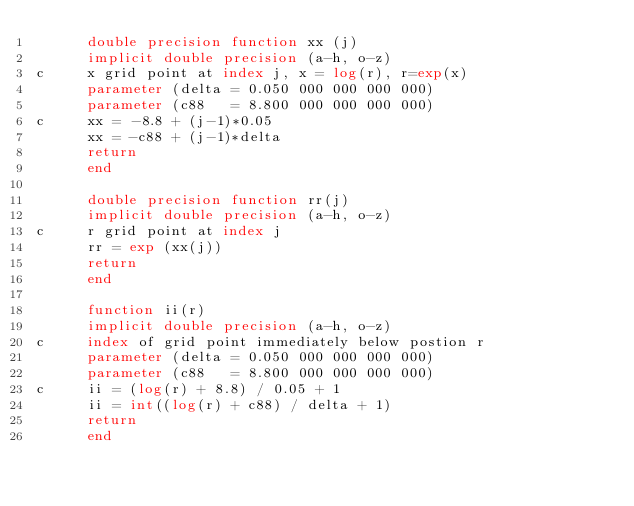Convert code to text. <code><loc_0><loc_0><loc_500><loc_500><_FORTRAN_>      double precision function xx (j)
      implicit double precision (a-h, o-z)
c     x grid point at index j, x = log(r), r=exp(x)
      parameter (delta = 0.050 000 000 000 000)
      parameter (c88   = 8.800 000 000 000 000)
c     xx = -8.8 + (j-1)*0.05
      xx = -c88 + (j-1)*delta
      return
      end

      double precision function rr(j)
      implicit double precision (a-h, o-z)
c     r grid point at index j
      rr = exp (xx(j))
      return
      end

      function ii(r)
      implicit double precision (a-h, o-z)
c     index of grid point immediately below postion r
      parameter (delta = 0.050 000 000 000 000)
      parameter (c88   = 8.800 000 000 000 000)
c     ii = (log(r) + 8.8) / 0.05 + 1
      ii = int((log(r) + c88) / delta + 1)
      return
      end
</code> 